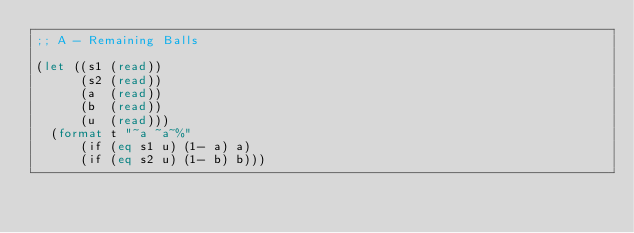<code> <loc_0><loc_0><loc_500><loc_500><_Lisp_>;; A - Remaining Balls

(let ((s1 (read))
      (s2 (read))
      (a  (read))
      (b  (read))
      (u  (read)))
  (format t "~a ~a~%"
      (if (eq s1 u) (1- a) a)
      (if (eq s2 u) (1- b) b)))
</code> 